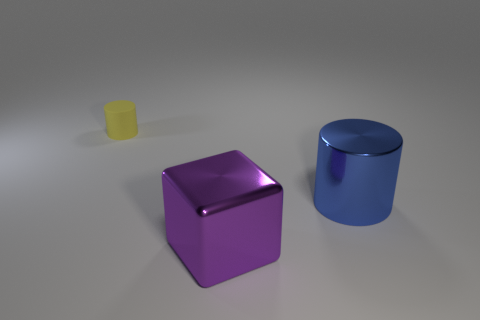Add 1 big cyan matte objects. How many objects exist? 4 Subtract all cylinders. How many objects are left? 1 Subtract 0 gray blocks. How many objects are left? 3 Subtract all yellow metallic spheres. Subtract all yellow rubber things. How many objects are left? 2 Add 1 yellow matte cylinders. How many yellow matte cylinders are left? 2 Add 1 large blue cylinders. How many large blue cylinders exist? 2 